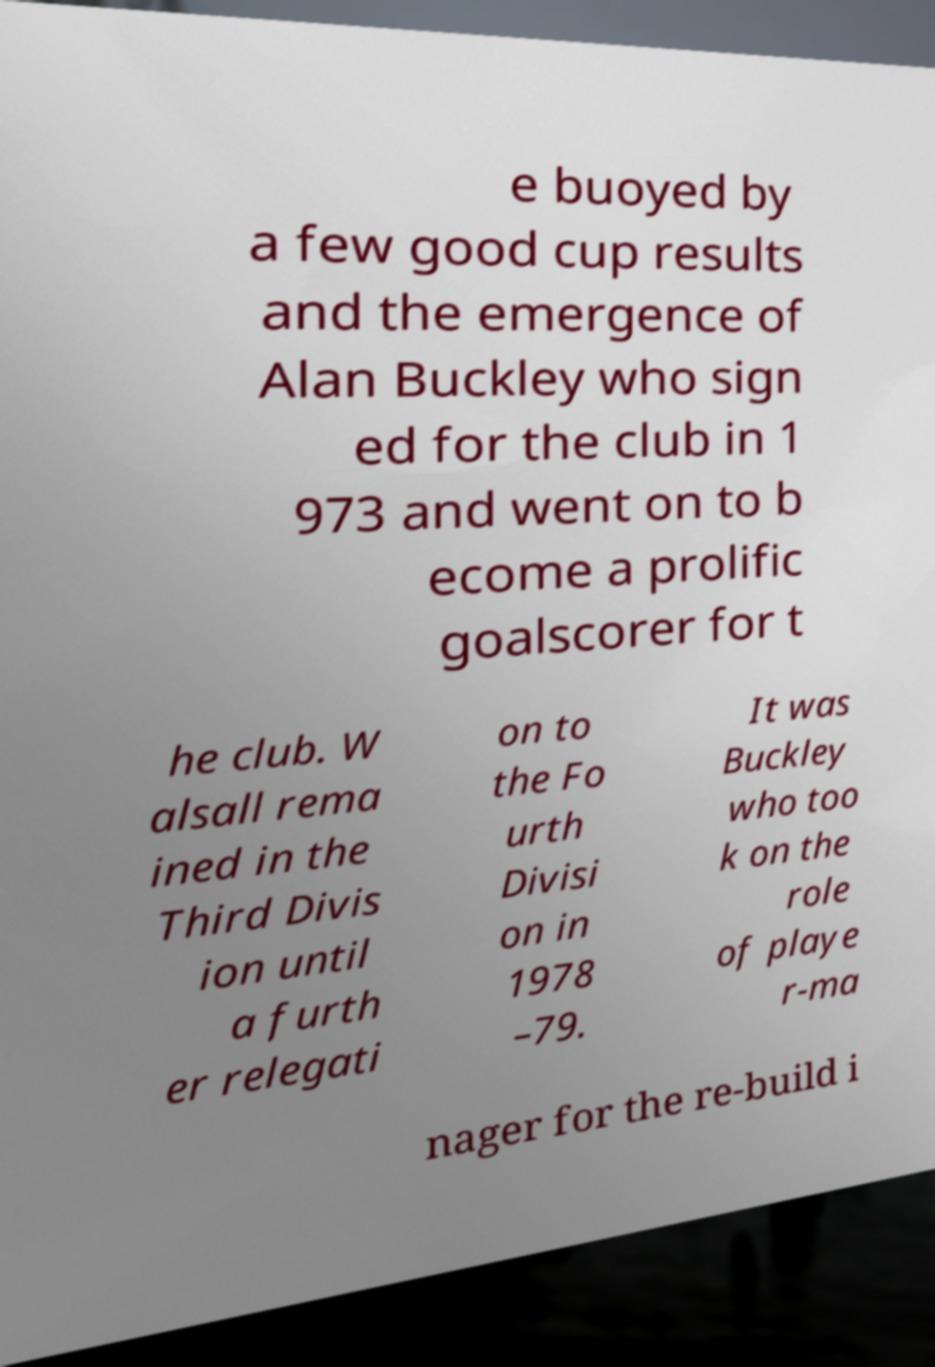I need the written content from this picture converted into text. Can you do that? e buoyed by a few good cup results and the emergence of Alan Buckley who sign ed for the club in 1 973 and went on to b ecome a prolific goalscorer for t he club. W alsall rema ined in the Third Divis ion until a furth er relegati on to the Fo urth Divisi on in 1978 –79. It was Buckley who too k on the role of playe r-ma nager for the re-build i 